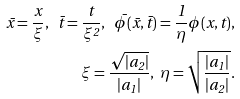Convert formula to latex. <formula><loc_0><loc_0><loc_500><loc_500>\bar { x } = \frac { x } { \xi } , \ \bar { t } = \frac { t } { \xi ^ { 2 } } , \ \bar { \phi } ( \bar { x } , \bar { t } ) = \frac { 1 } { \eta } \phi ( x , t ) , \\ \xi = \frac { \sqrt { | a _ { 2 } | } } { | a _ { 1 } | } , \ \eta = \sqrt { \frac { | a _ { 1 } | } { | a _ { 2 } | } } .</formula> 